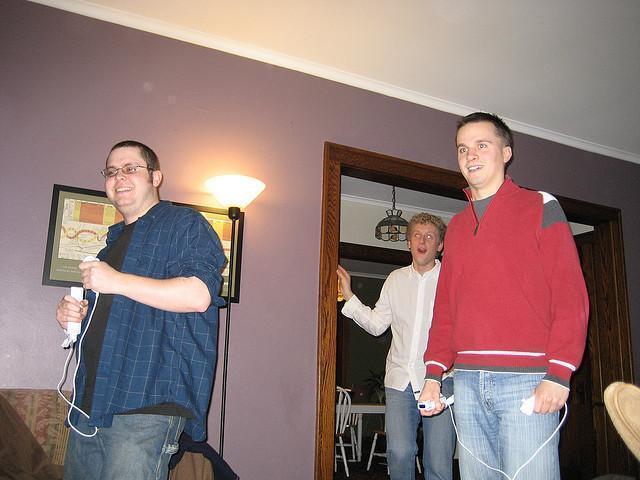What are they looking at?
Select the accurate answer and provide justification: `Answer: choice
Rationale: srationale.`
Options: Small child, soap opera, video screen, trained puppy. Answer: video screen.
Rationale: They are looking at the tv while playing nintendo wii. 